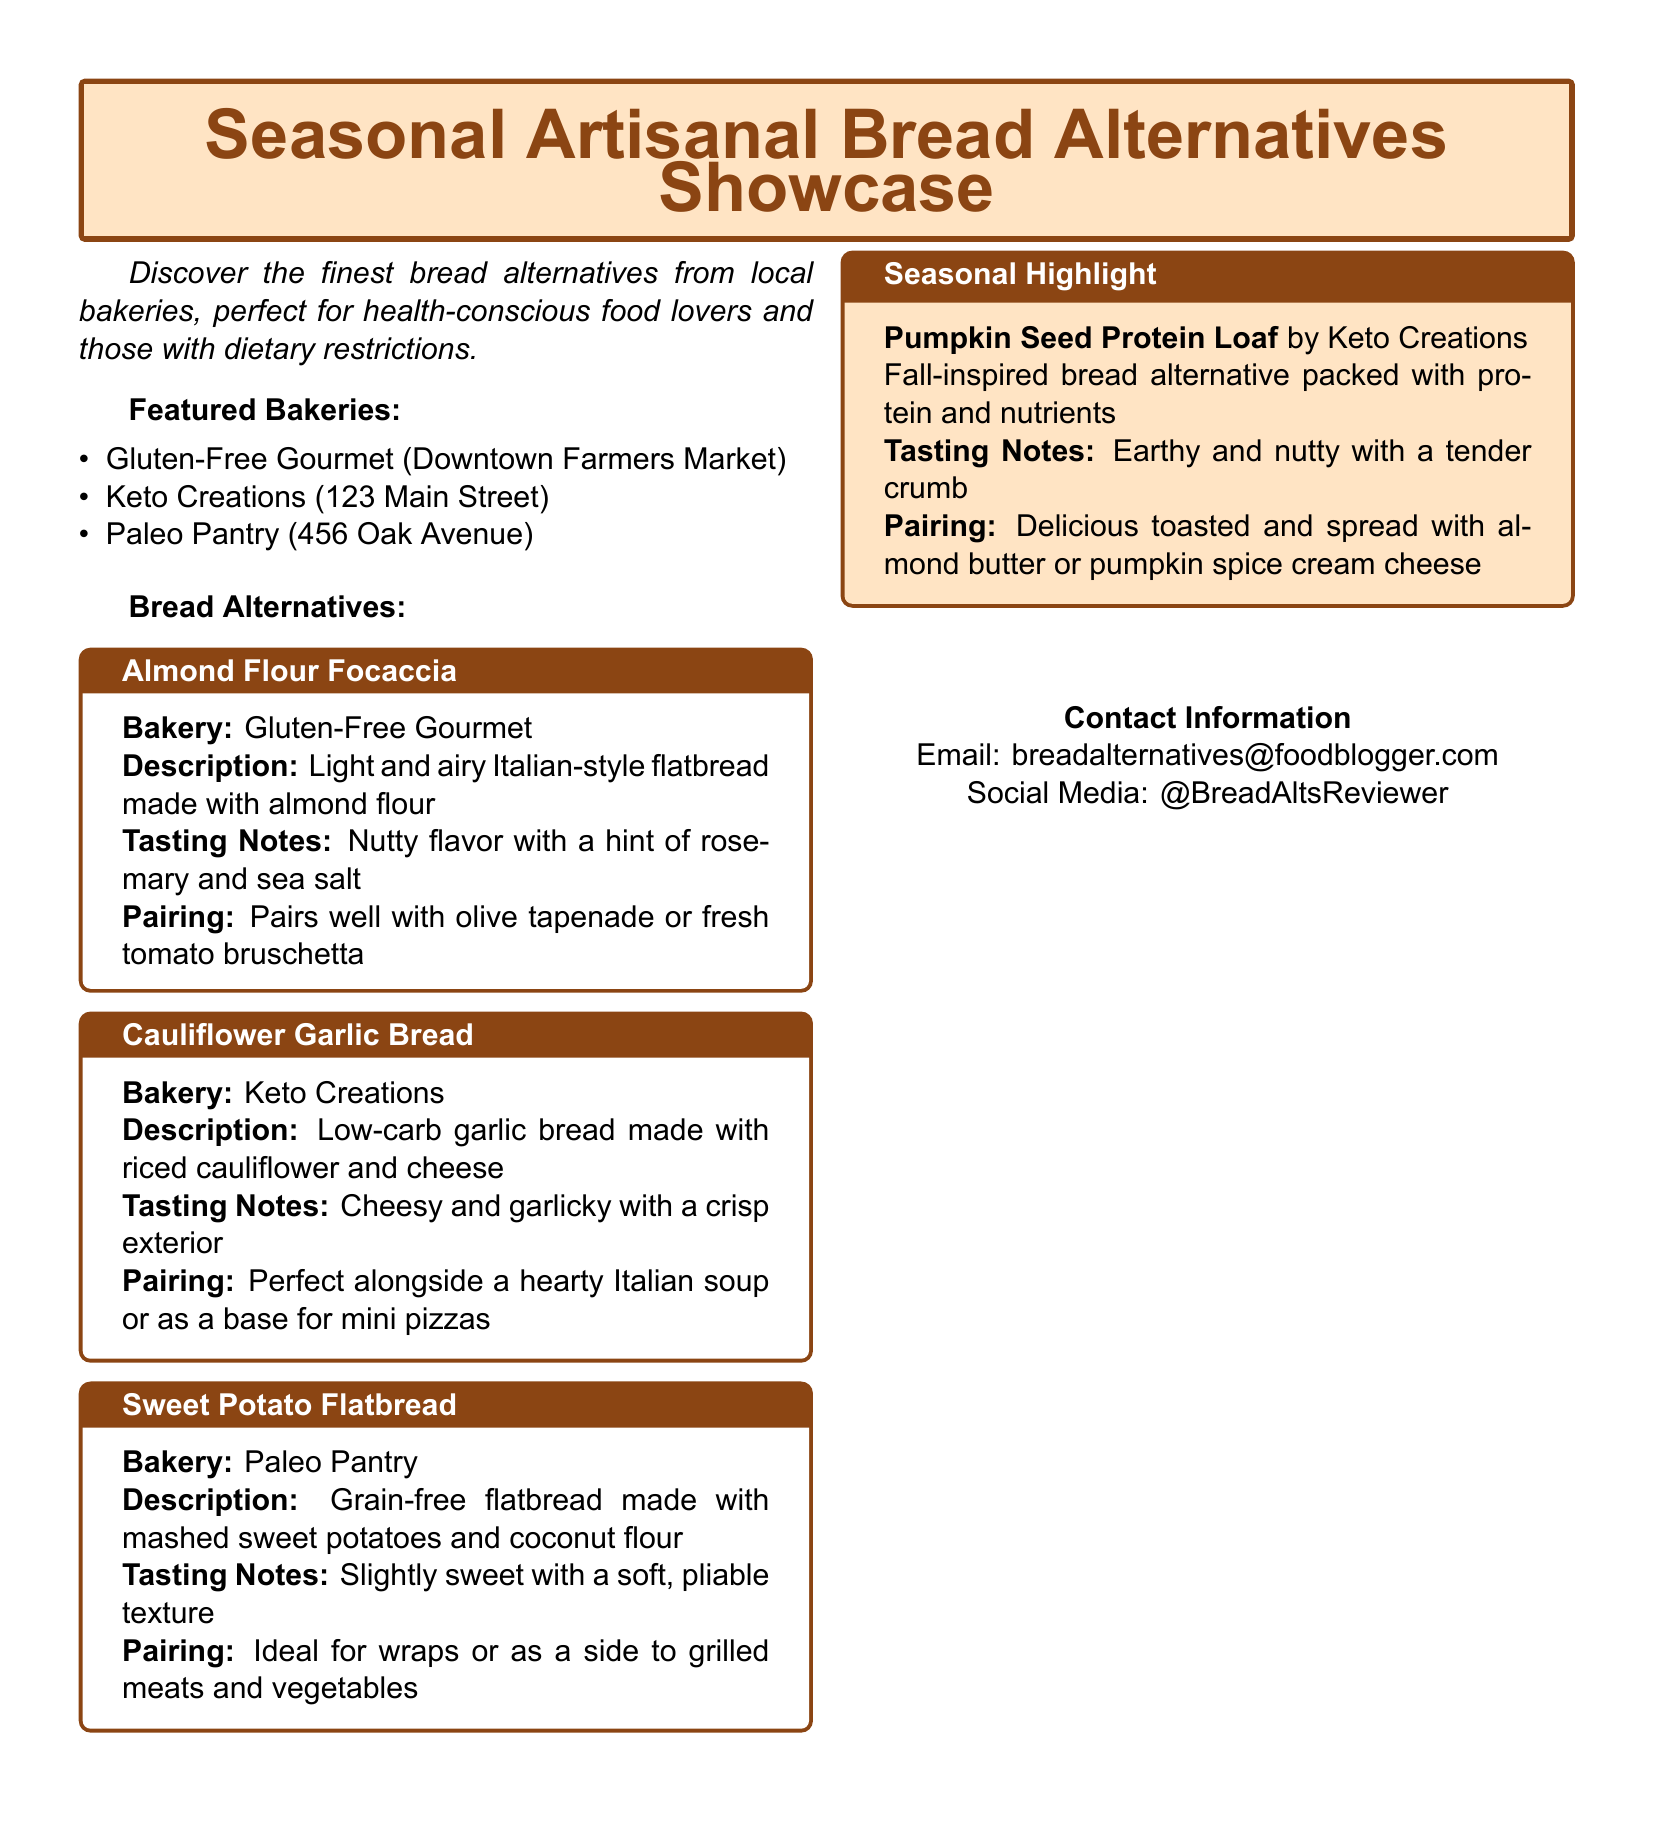What is the name of the bakery that offers Almond Flour Focaccia? The bakery that offers Almond Flour Focaccia is Gluten-Free Gourmet.
Answer: Gluten-Free Gourmet What is the primary ingredient of the Cauliflower Garlic Bread? The primary ingredient of the Cauliflower Garlic Bread is riced cauliflower.
Answer: Riced cauliflower What is the tasting note for the Sweet Potato Flatbread? The tasting note for the Sweet Potato Flatbread is slightly sweet with a soft, pliable texture.
Answer: Slightly sweet with a soft, pliable texture Which seasonal highlight bread is mentioned? The seasonal highlight bread mentioned is Pumpkin Seed Protein Loaf.
Answer: Pumpkin Seed Protein Loaf What is the pairing suggestion for the Almond Flour Focaccia? The pairing suggestion for the Almond Flour Focaccia is olive tapenade or fresh tomato bruschetta.
Answer: Olive tapenade or fresh tomato bruschetta How many bakeries are featured in the catalog? The number of bakeries featured in the catalog is three.
Answer: Three What is the contact email provided in the document? The contact email provided in the document is breadalternatives@foodblogger.com.
Answer: breadalternatives@foodblogger.com Which bakery is associated with the grain-free flatbread? The bakery associated with the grain-free flatbread is Paleo Pantry.
Answer: Paleo Pantry What flavor notes are described for the Pumpkin Seed Protein Loaf? The flavor notes described for the Pumpkin Seed Protein Loaf are earthy and nutty.
Answer: Earthy and nutty 